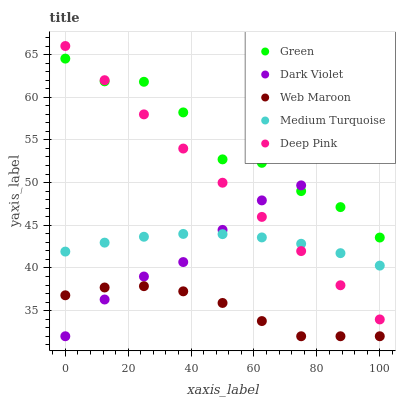Does Web Maroon have the minimum area under the curve?
Answer yes or no. Yes. Does Green have the maximum area under the curve?
Answer yes or no. Yes. Does Deep Pink have the minimum area under the curve?
Answer yes or no. No. Does Deep Pink have the maximum area under the curve?
Answer yes or no. No. Is Deep Pink the smoothest?
Answer yes or no. Yes. Is Green the roughest?
Answer yes or no. Yes. Is Green the smoothest?
Answer yes or no. No. Is Deep Pink the roughest?
Answer yes or no. No. Does Web Maroon have the lowest value?
Answer yes or no. Yes. Does Deep Pink have the lowest value?
Answer yes or no. No. Does Deep Pink have the highest value?
Answer yes or no. Yes. Does Green have the highest value?
Answer yes or no. No. Is Web Maroon less than Deep Pink?
Answer yes or no. Yes. Is Green greater than Medium Turquoise?
Answer yes or no. Yes. Does Green intersect Dark Violet?
Answer yes or no. Yes. Is Green less than Dark Violet?
Answer yes or no. No. Is Green greater than Dark Violet?
Answer yes or no. No. Does Web Maroon intersect Deep Pink?
Answer yes or no. No. 